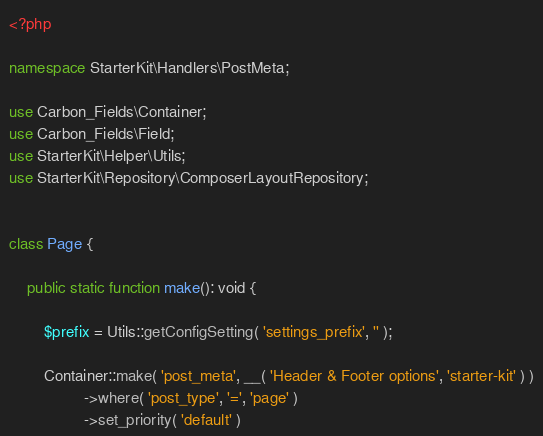<code> <loc_0><loc_0><loc_500><loc_500><_PHP_><?php

namespace StarterKit\Handlers\PostMeta;

use Carbon_Fields\Container;
use Carbon_Fields\Field;
use StarterKit\Helper\Utils;
use StarterKit\Repository\ComposerLayoutRepository;


class Page {
	
	public static function make(): void {
		
		$prefix = Utils::getConfigSetting( 'settings_prefix', '' );
		
		Container::make( 'post_meta', __( 'Header & Footer options', 'starter-kit' ) )
		         ->where( 'post_type', '=', 'page' )
		         ->set_priority( 'default' )</code> 